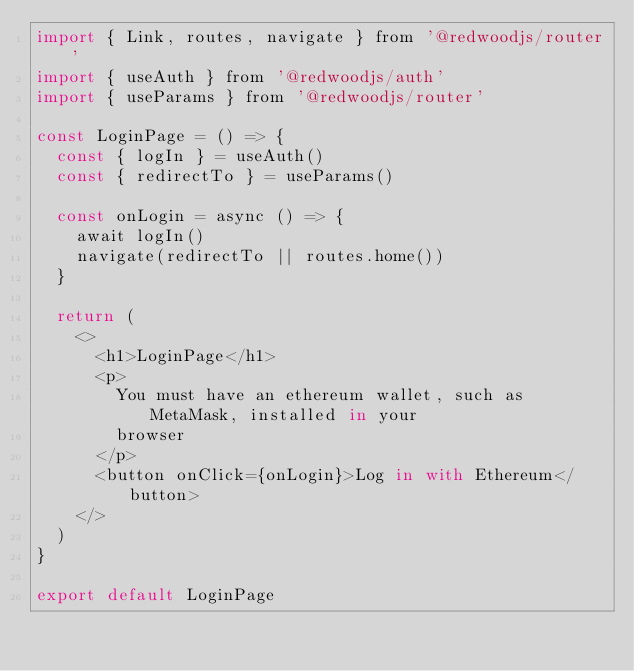<code> <loc_0><loc_0><loc_500><loc_500><_JavaScript_>import { Link, routes, navigate } from '@redwoodjs/router'
import { useAuth } from '@redwoodjs/auth'
import { useParams } from '@redwoodjs/router'

const LoginPage = () => {
  const { logIn } = useAuth()
  const { redirectTo } = useParams()

  const onLogin = async () => {
    await logIn()
    navigate(redirectTo || routes.home())
  }

  return (
    <>
      <h1>LoginPage</h1>
      <p>
        You must have an ethereum wallet, such as MetaMask, installed in your
        browser
      </p>
      <button onClick={onLogin}>Log in with Ethereum</button>
    </>
  )
}

export default LoginPage
</code> 